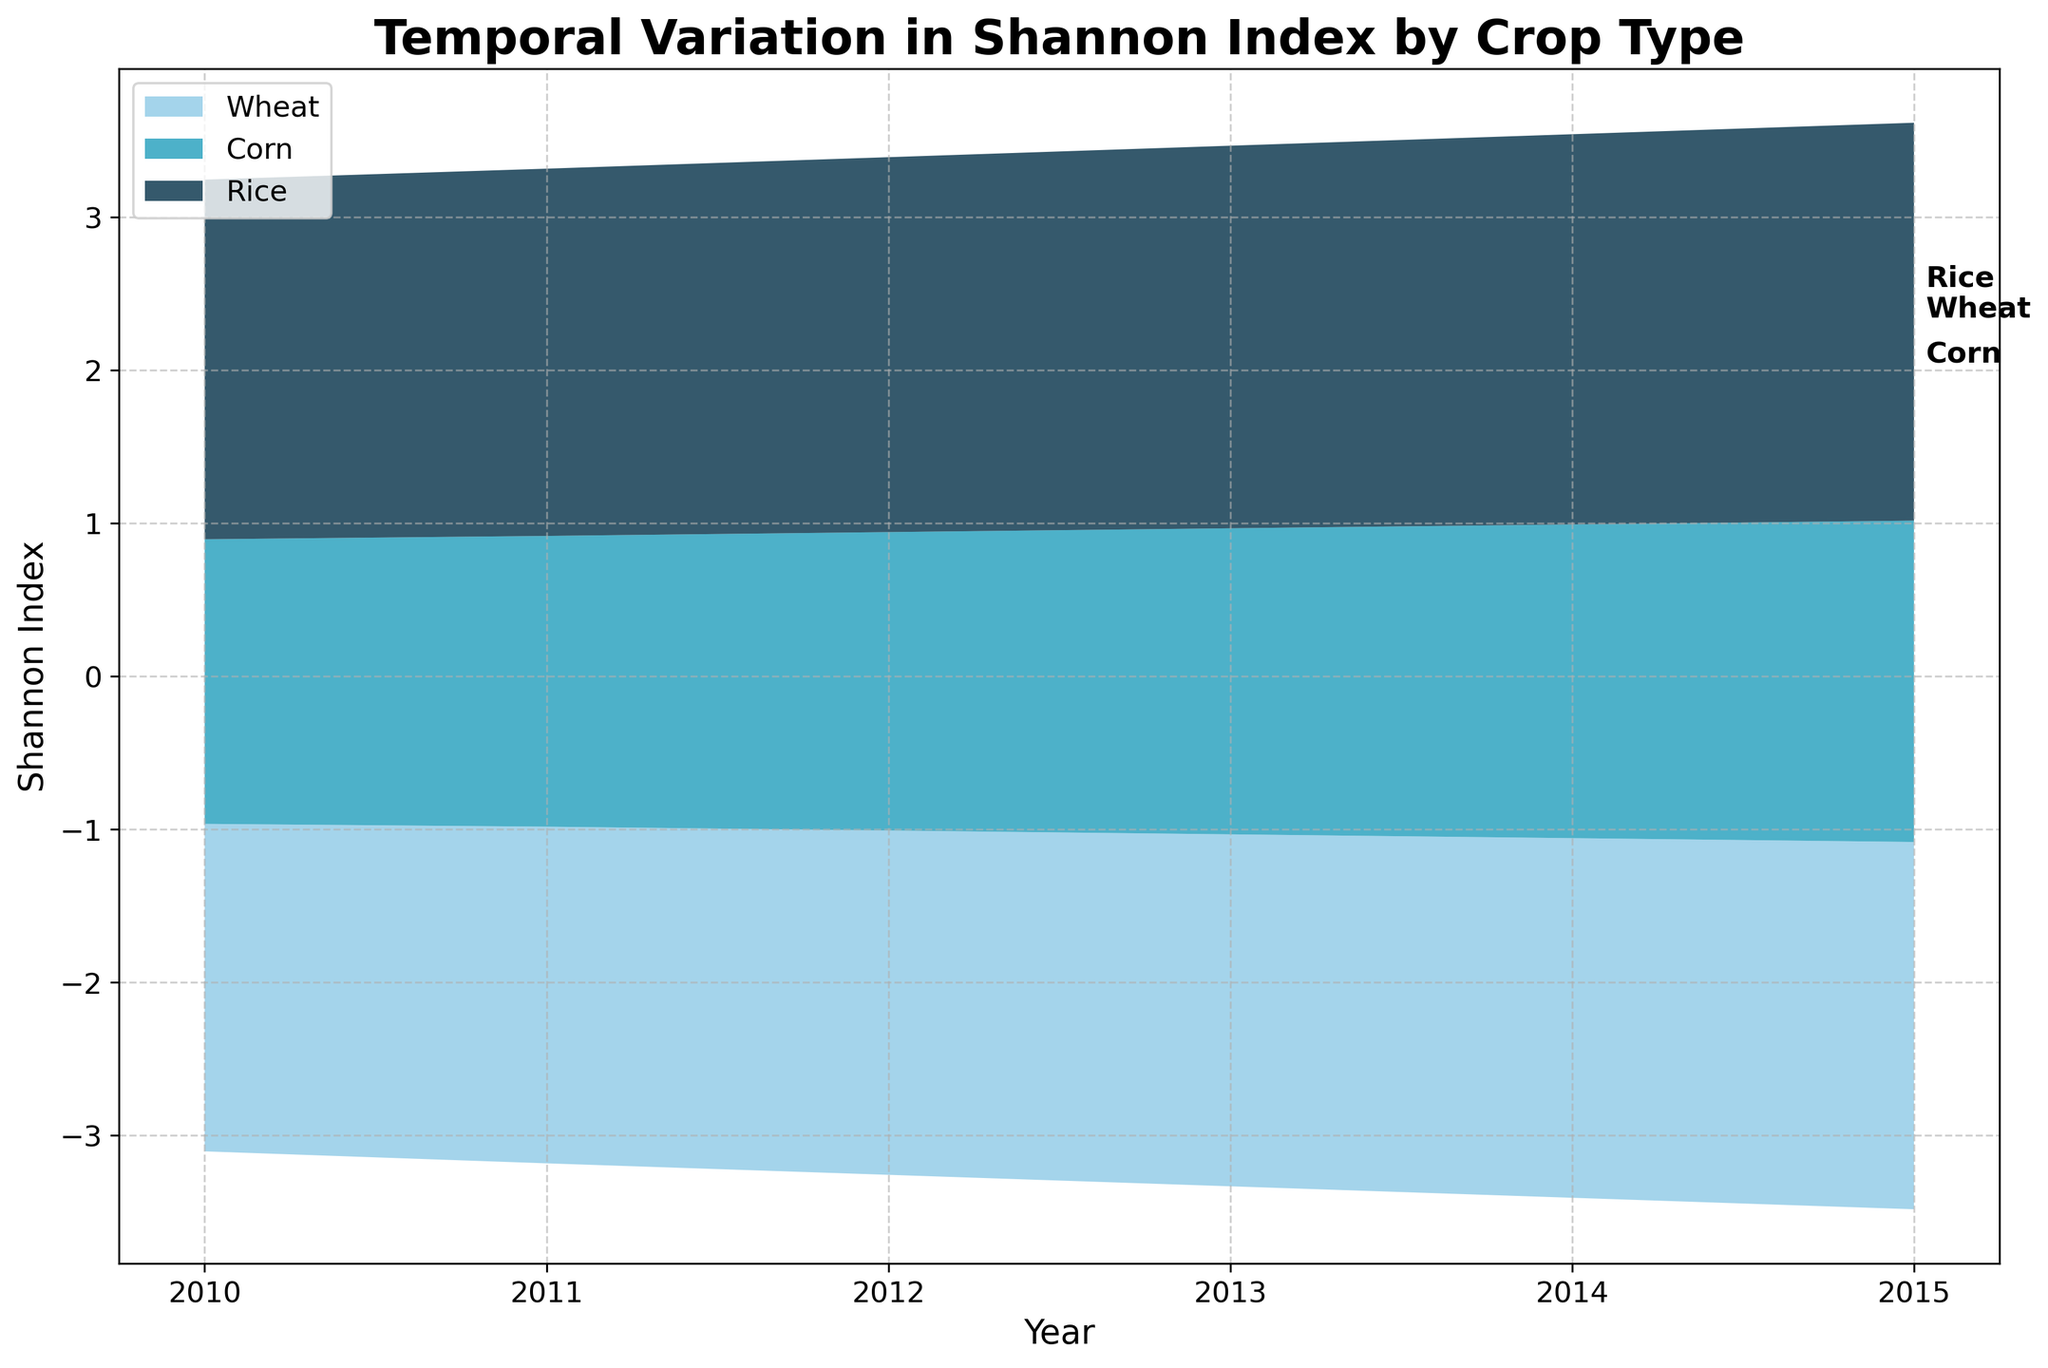what is the title of the graph? The title of the graph is usually the largest text located at the top of the figure. It gives a summary of what the graph represents.
Answer: Temporal Variation in Shannon Index by Crop Type What does the y-axis represent? The y-axis typically represents the variable being measured. In this graph, the label on the y-axis indicates it measures the Shannon Index.
Answer: Shannon Index Which crop type shows the highest Shannon Index consistently over the years? To determine the crop type with the highest consistent Shannon Index, look at the topmost layer of the stream graph across all years. This layer represents the highest Shannon Index values consistently.
Answer: Rice How does the Shannon Index for Corn change from 2010 to 2015? To observe the Shannon Index change for Corn, track the layer corresponding to Corn from 2010 to 2015. Note the start and end points in the y-values. The Shannon Index for Corn starts at 1.86 in 2010 and ends at 2.10 in 2015.
Answer: Increases Compare the Shannon Index variation between Wheat and Rice from 2010 to 2015. To compare the variations, examine how the y-values change for Wheat and Rice layers for these years. Wheat goes from 2.14 to 2.40 and Rice from 2.35 to 2.60. Calculate the differences: Wheat changes by 0.26 (2.40 - 2.14) and Rice by 0.25 (2.60 - 2.35).
Answer: Wheat varies more than Rice What is the approximate difference in the Shannon Index between Wheat and Corn in 2012? To find the difference, look at the y-values for Wheat and Corn for 2012. Wheat has a value of 2.25, and Corn has a value of 1.95. Subtract the lower value from the higher value: 2.25 - 1.95.
Answer: 0.30 How many crop types are represented in the graph? The legend or the number of distinct color bands in the stream graph can tell us the number of crop types. There are three distinct color bands representing Wheat, Corn, and Rice.
Answer: 3 Identify the crop type with the least variation in its Shannon Index over the years. Examine the layers' heights in the stream graph for each crop type over the years. The crop type with the least amount of change or smallest layer fluctuation has the least variation. Corn shows the least variation as its values change the least over time.
Answer: Corn 